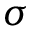<formula> <loc_0><loc_0><loc_500><loc_500>\sigma</formula> 